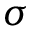<formula> <loc_0><loc_0><loc_500><loc_500>\sigma</formula> 